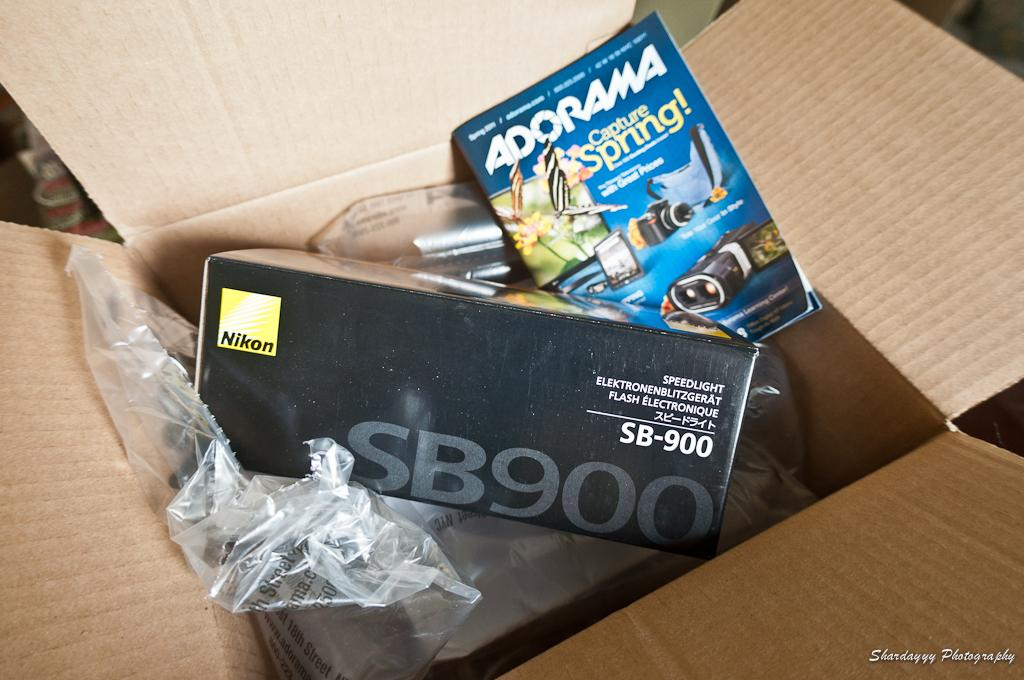<image>
Create a compact narrative representing the image presented. The packaging for a Nikon SB900 camera flash and an Adorama catalog. 